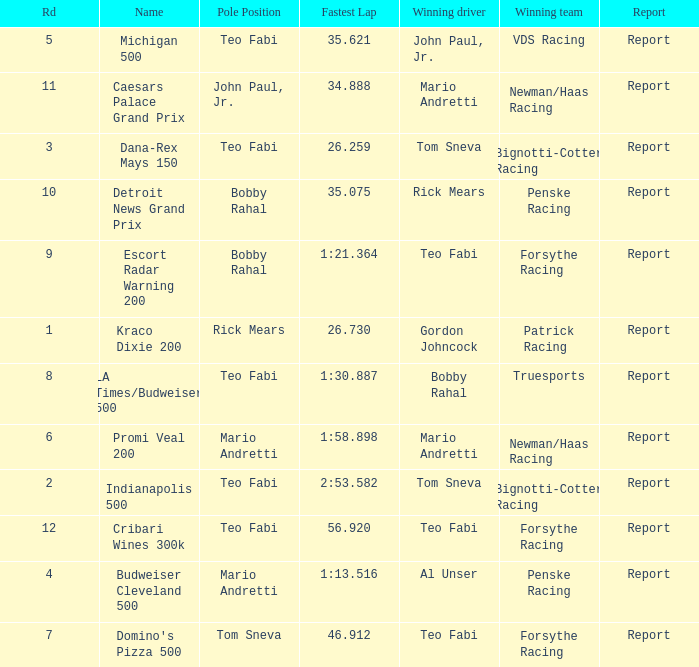How many winning drivers were there in the race that had a fastest lap time of 56.920? 1.0. 